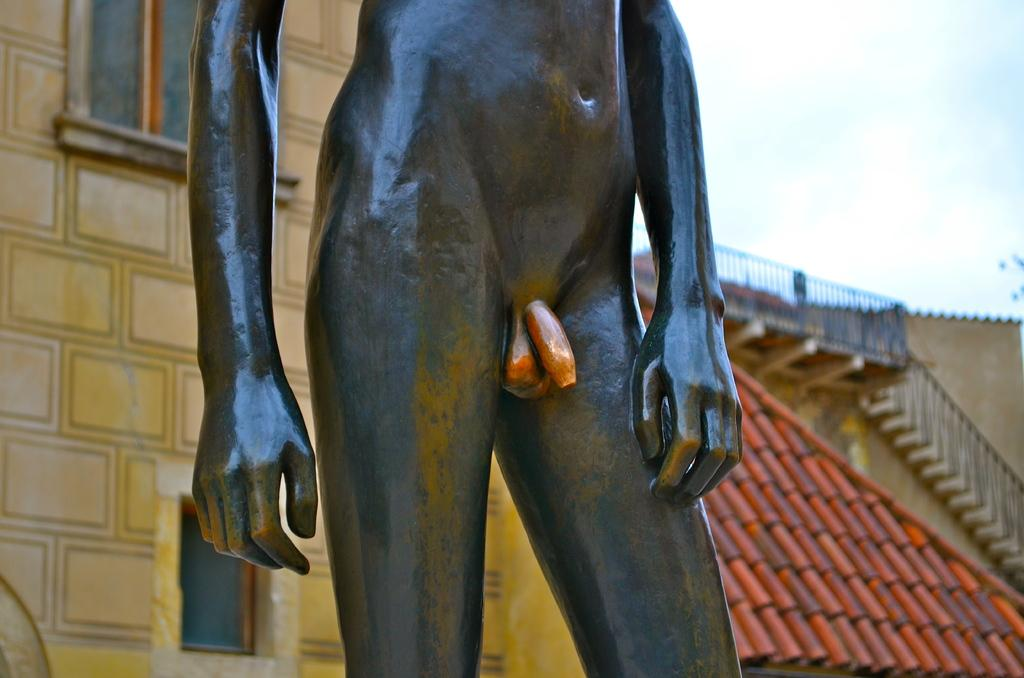What is the main subject of the image? There is a statue of a person in the image. What can be seen in the background of the image? There are buildings behind the statue. What architectural feature is on the right side of the image? There is a staircase on the right side of the image leading to a building. What is visible at the top of the image? The sky is visible at the top of the image. What type of horn can be heard in the image? There is no horn present in the image, and therefore no sound can be heard. 